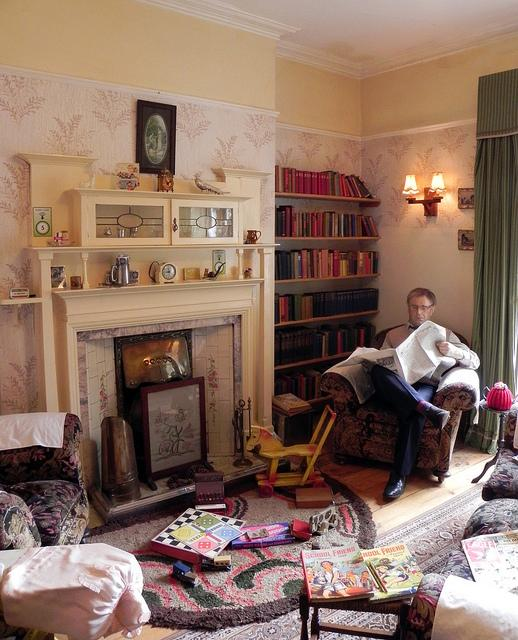How is the game laying on top of the chess board called? ludo 